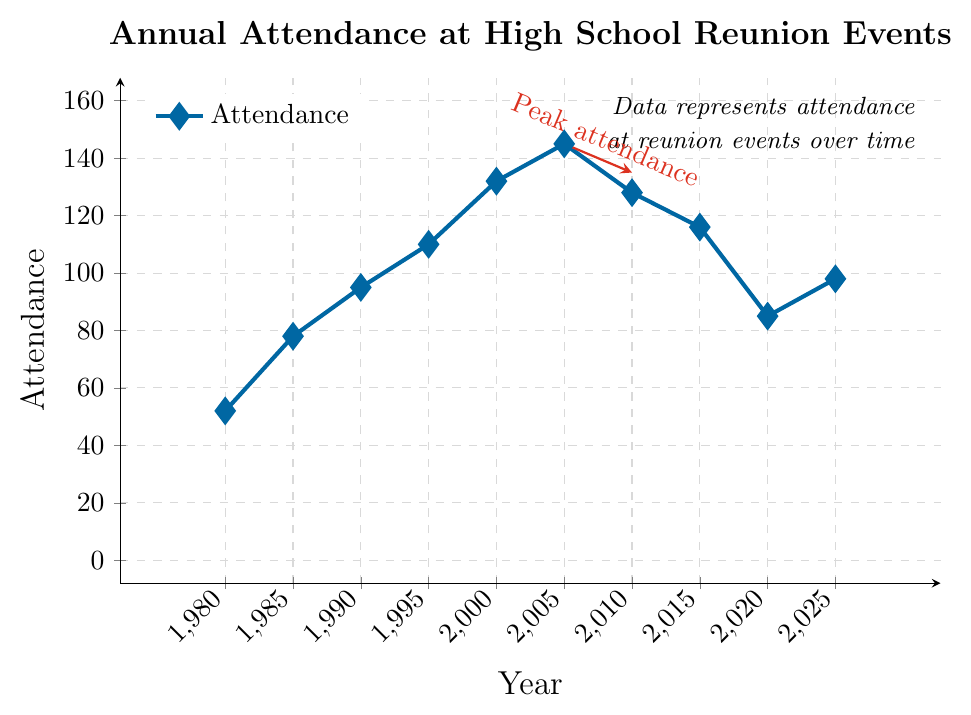What year had the peak attendance? The peak attendance is indicated by the point with the highest y-value on the graph, which is marked. It is also highlighted by the red arrow labeled "Peak attendance".
Answer: 2005 What is the trend in attendance from 2010 to 2020? Inspect the y-values from 2010 to 2020. The attendance decreases from 128 in 2010 to 85 in 2020. Therefore, the trend is downward.
Answer: Downward What are the years with more than 100 attendees? Look at the data points on the graph where the y-values are greater than 100. They are 1995, 2000, 2005, 2010, and 2015.
Answer: 1995, 2000, 2005, 2010, 2015 What is the difference in attendance between the years 1990 and 2000? Subtract the attendance in 1990 from the attendance in 2000: 132 - 95 = 37.
Answer: 37 How much did the attendance increase from 1980 to 1995? Subtract the attendance in 1980 from the attendance in 1995: 110 - 52 = 58.
Answer: 58 Which year had the lowest attendance? The point with the lowest y-value on the graph represents the lowest attendance, which is in 1980.
Answer: 1980 What is the average attendance for the years 1980, 1985, and 1990? Calculate the average by summing the attendance for these years and dividing by 3: (52 + 78 + 95) / 3 = 75
Answer: 75 How did the attendance change from 2015 to 2025? Track the attendance from 2015 to 2025 on the graph. The attendance decreased from 116 to 98.
Answer: Decreased During which decade did the attendance increase the most? Compare the increase over each decade: 
1980s: 78 - 52 = 26,
1990s: 110 - 95 = 15,
2000s: 145 - 132 = 13,
2010s: 128 - 116 = 12,
2020s (projected): 98 - 85 = 13.
The decade with the greatest increase is from 1980 to 1989.
Answer: 1980s 